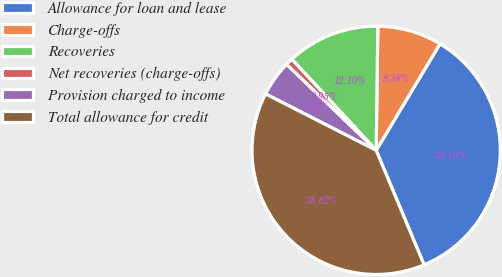Convert chart to OTSL. <chart><loc_0><loc_0><loc_500><loc_500><pie_chart><fcel>Allowance for loan and lease<fcel>Charge-offs<fcel>Recoveries<fcel>Net recoveries (charge-offs)<fcel>Provision charged to income<fcel>Total allowance for credit<nl><fcel>35.1%<fcel>8.38%<fcel>12.1%<fcel>0.95%<fcel>4.66%<fcel>38.82%<nl></chart> 